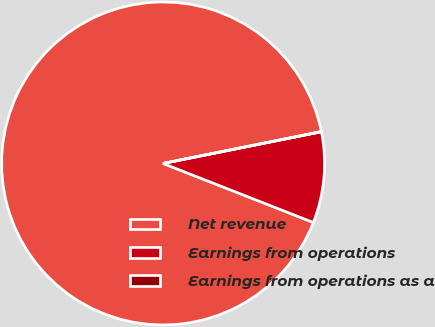Convert chart to OTSL. <chart><loc_0><loc_0><loc_500><loc_500><pie_chart><fcel>Net revenue<fcel>Earnings from operations<fcel>Earnings from operations as a<nl><fcel>90.88%<fcel>9.1%<fcel>0.02%<nl></chart> 